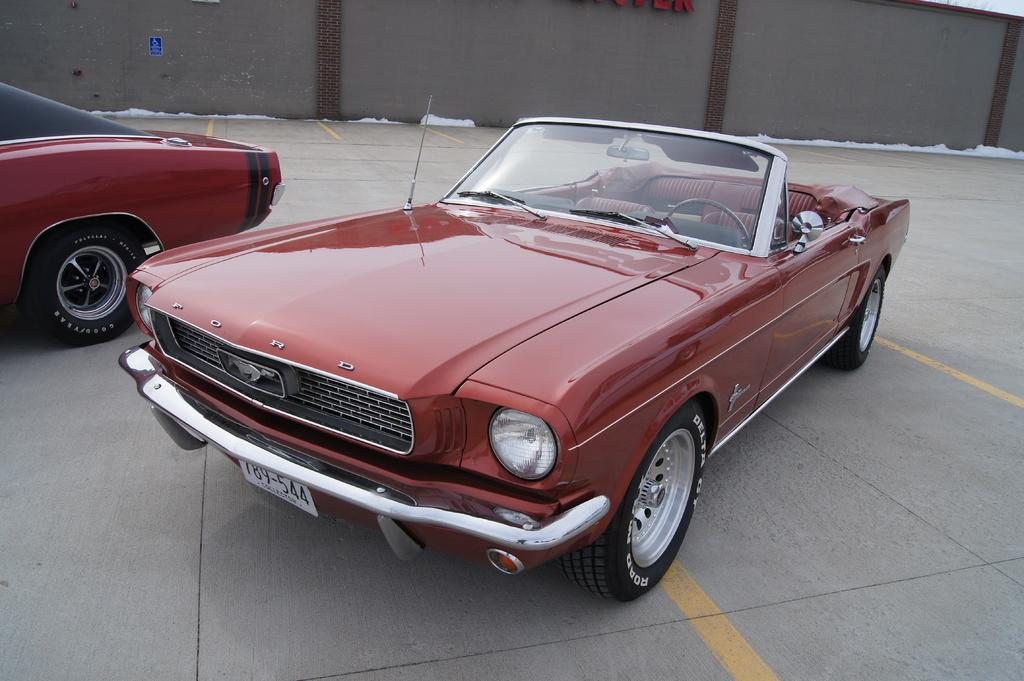What can be seen in the center of the image? There are two cars in the center of the image. What is visible in the background of the image? There is a wall and text visible in the background of the image. What type of material is present in the background of the image? Cotton is present in the background of the image. What is at the bottom of the image? There is a walkway at the bottom of the image. What type of match is being played in the image? There is no match being played in the image; it features two cars, a wall, text, cotton, and a walkway. What authority is depicted in the image? There is no authority depicted in the image; it is a scene with two cars, a wall, text, cotton, and a walkway. 